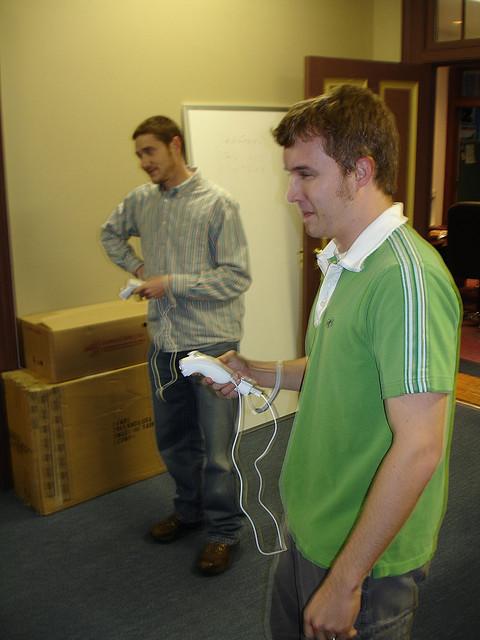Are the boys texting?
Write a very short answer. No. What kind of device is the guy in the green shirt holding in his hand?
Give a very brief answer. Wii remote. What color is the boy's shirt?
Answer briefly. Green. What is the boy standing on?
Give a very brief answer. Floor. What is stacked next to wall on left?
Answer briefly. Boxes. What kind of shoes is the man wearing?
Quick response, please. Boots. What are the men doing?
Keep it brief. Playing wii. Are these men inside or outside?
Give a very brief answer. Inside. 